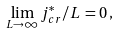<formula> <loc_0><loc_0><loc_500><loc_500>\lim _ { L \rightarrow \infty } j ^ { * } _ { c r } / L \, = 0 \, ,</formula> 